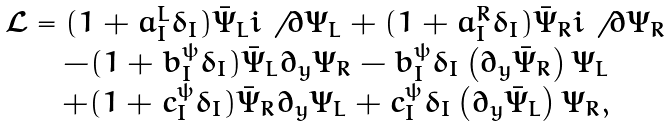Convert formula to latex. <formula><loc_0><loc_0><loc_500><loc_500>\begin{array} { c } \mathcal { L } = ( 1 + a ^ { L } _ { I } \delta _ { I } ) \bar { \Psi } _ { L } i \not \, \partial \Psi _ { L } + ( 1 + a ^ { R } _ { I } \delta _ { I } ) \bar { \Psi } _ { R } i \not \, \partial \Psi _ { R } \\ - ( 1 + b _ { I } ^ { \psi } \delta _ { I } ) \bar { \Psi } _ { L } \partial _ { y } \Psi _ { R } - b _ { I } ^ { \psi } \delta _ { I } \left ( \partial _ { y } \bar { \Psi } _ { R } \right ) \Psi _ { L } \\ + ( 1 + c _ { I } ^ { \psi } \delta _ { I } ) \bar { \Psi } _ { R } \partial _ { y } \Psi _ { L } + c _ { I } ^ { \psi } \delta _ { I } \left ( \partial _ { y } \bar { \Psi } _ { L } \right ) \Psi _ { R } , \\ \end{array}</formula> 